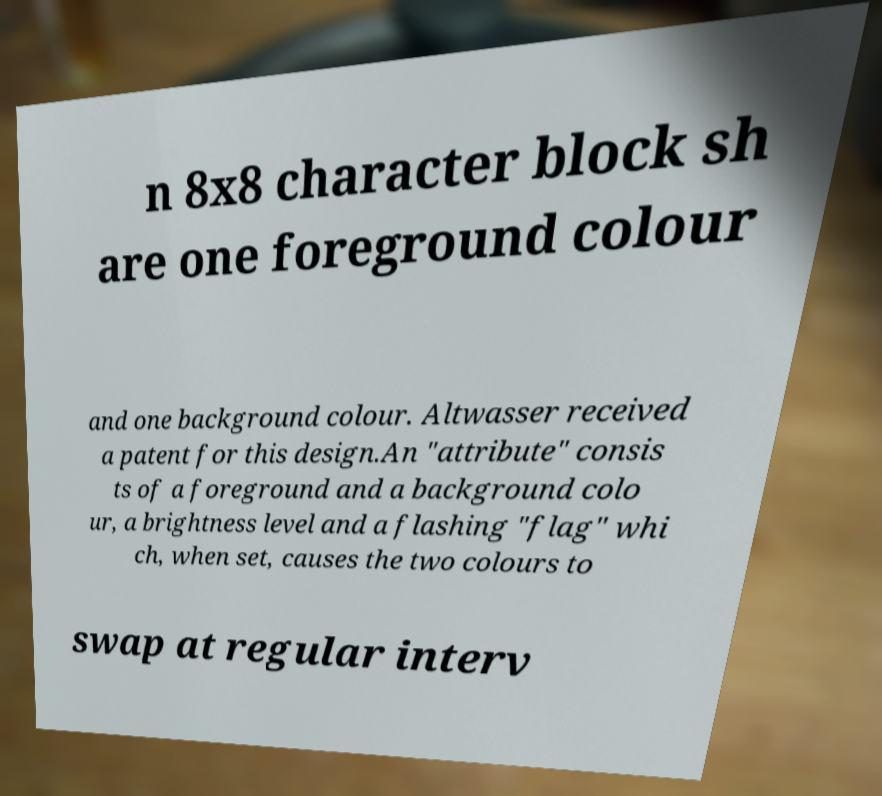For documentation purposes, I need the text within this image transcribed. Could you provide that? n 8x8 character block sh are one foreground colour and one background colour. Altwasser received a patent for this design.An "attribute" consis ts of a foreground and a background colo ur, a brightness level and a flashing "flag" whi ch, when set, causes the two colours to swap at regular interv 